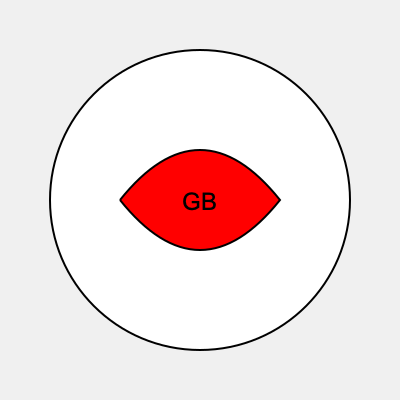Which British field hockey team does this logo represent? 1. The logo features a circular design with a white background and black outline.
2. Inside the circle, there's a distinctive red shape resembling a stylized hockey stick or a curved letter 'C'.
3. At the center of the logo, we see the letters 'GB' in bold black text.
4. The 'GB' stands for Great Britain, indicating this is a national team logo.
5. The red color is significant as it's one of the primary colors of the Union Jack, the flag of the United Kingdom.
6. This combination of elements - the circular shape, the red curved design, and the 'GB' lettering - is characteristic of the Great Britain field hockey team's logo.
7. The Great Britain field hockey team represents the UK in international competitions, including the Olympic Games.
Answer: Great Britain 